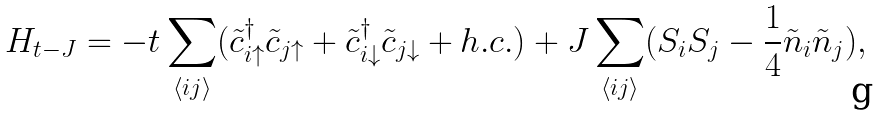Convert formula to latex. <formula><loc_0><loc_0><loc_500><loc_500>& H _ { t - J } = - t \sum _ { \langle i j \rangle } ( \tilde { c } ^ { \dag } _ { i \uparrow } \tilde { c } _ { j \uparrow } + \tilde { c } ^ { \dag } _ { i \downarrow } \tilde { c } _ { j \downarrow } + h . c . ) + J \sum _ { \langle i j \rangle } ( { S } _ { i } { S } _ { j } - \frac { 1 } { 4 } \tilde { n } _ { i } \tilde { n } _ { j } ) ,</formula> 